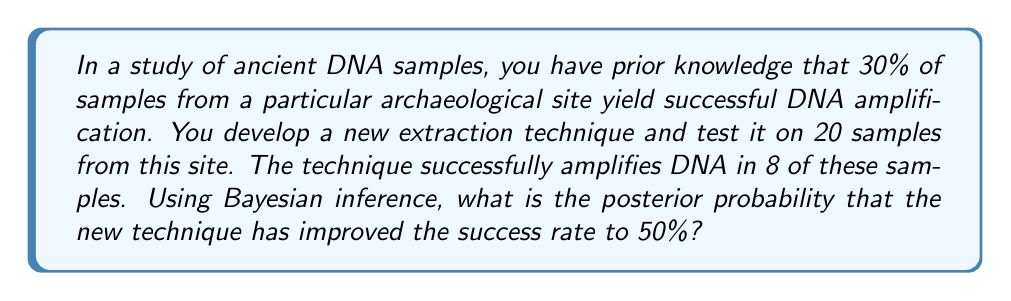Teach me how to tackle this problem. Let's approach this step-by-step using Bayesian inference:

1) Define our hypotheses:
   $H_0$: The new technique has not improved (success rate = 30%)
   $H_1$: The new technique has improved (success rate = 50%)

2) Define our prior probabilities:
   $P(H_0) = 0.5$ (assuming equal prior probabilities)
   $P(H_1) = 0.5$

3) Calculate the likelihood of observing 8 successes out of 20 trials for each hypothesis:
   For $H_0$: $P(D|H_0) = \binom{20}{8} (0.3)^8 (0.7)^{12}$
   For $H_1$: $P(D|H_1) = \binom{20}{8} (0.5)^8 (0.5)^{12}$

4) Calculate these values:
   $P(D|H_0) = \binom{20}{8} (0.3)^8 (0.7)^{12} \approx 0.1662$
   $P(D|H_1) = \binom{20}{8} (0.5)^8 (0.5)^{12} \approx 0.1201$

5) Apply Bayes' theorem:
   $$P(H_1|D) = \frac{P(D|H_1)P(H_1)}{P(D|H_1)P(H_1) + P(D|H_0)P(H_0)}$$

6) Substitute the values:
   $$P(H_1|D) = \frac{0.1201 * 0.5}{0.1201 * 0.5 + 0.1662 * 0.5}$$

7) Simplify:
   $$P(H_1|D) = \frac{0.1201}{0.1201 + 0.1662} \approx 0.4195$$

Therefore, the posterior probability that the new technique has improved the success rate to 50% is approximately 0.4195 or 41.95%.
Answer: 0.4195 